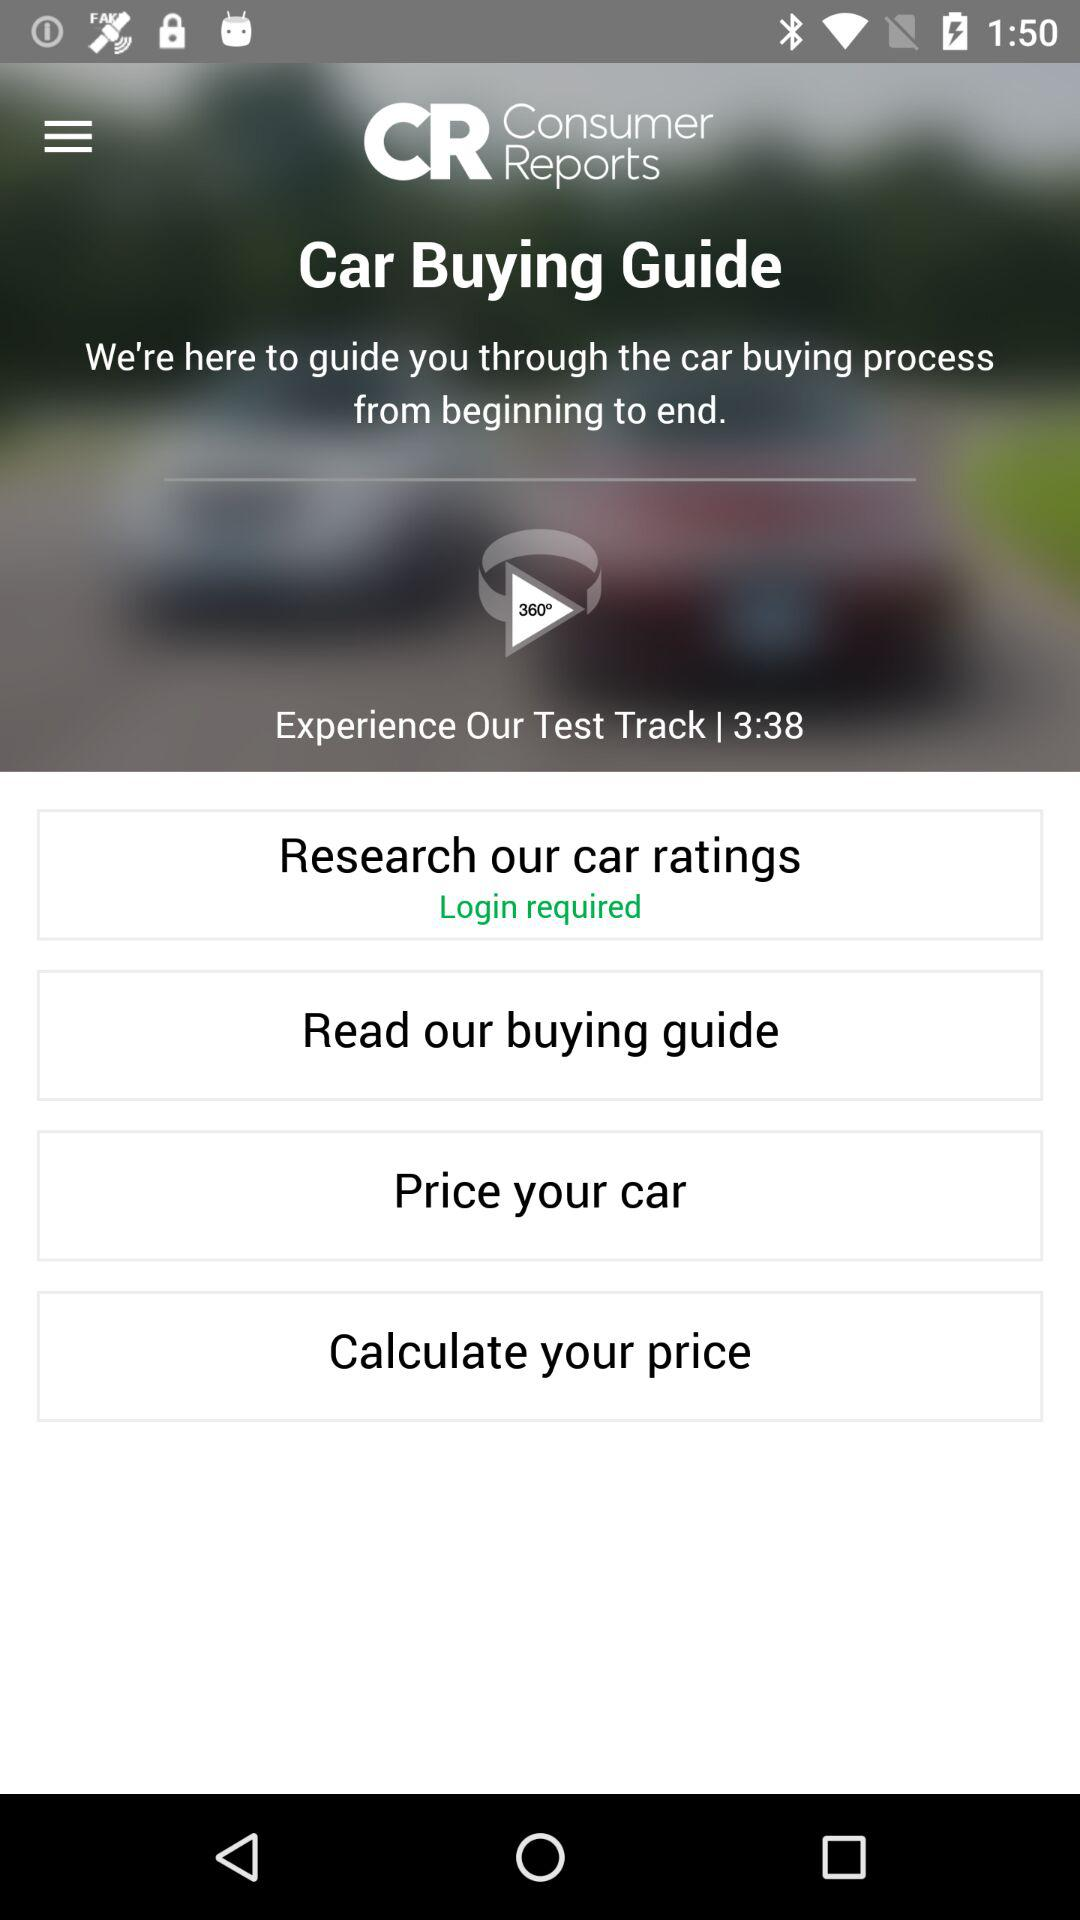What is the name of the application? The name of the application is "Consumer Reports". 